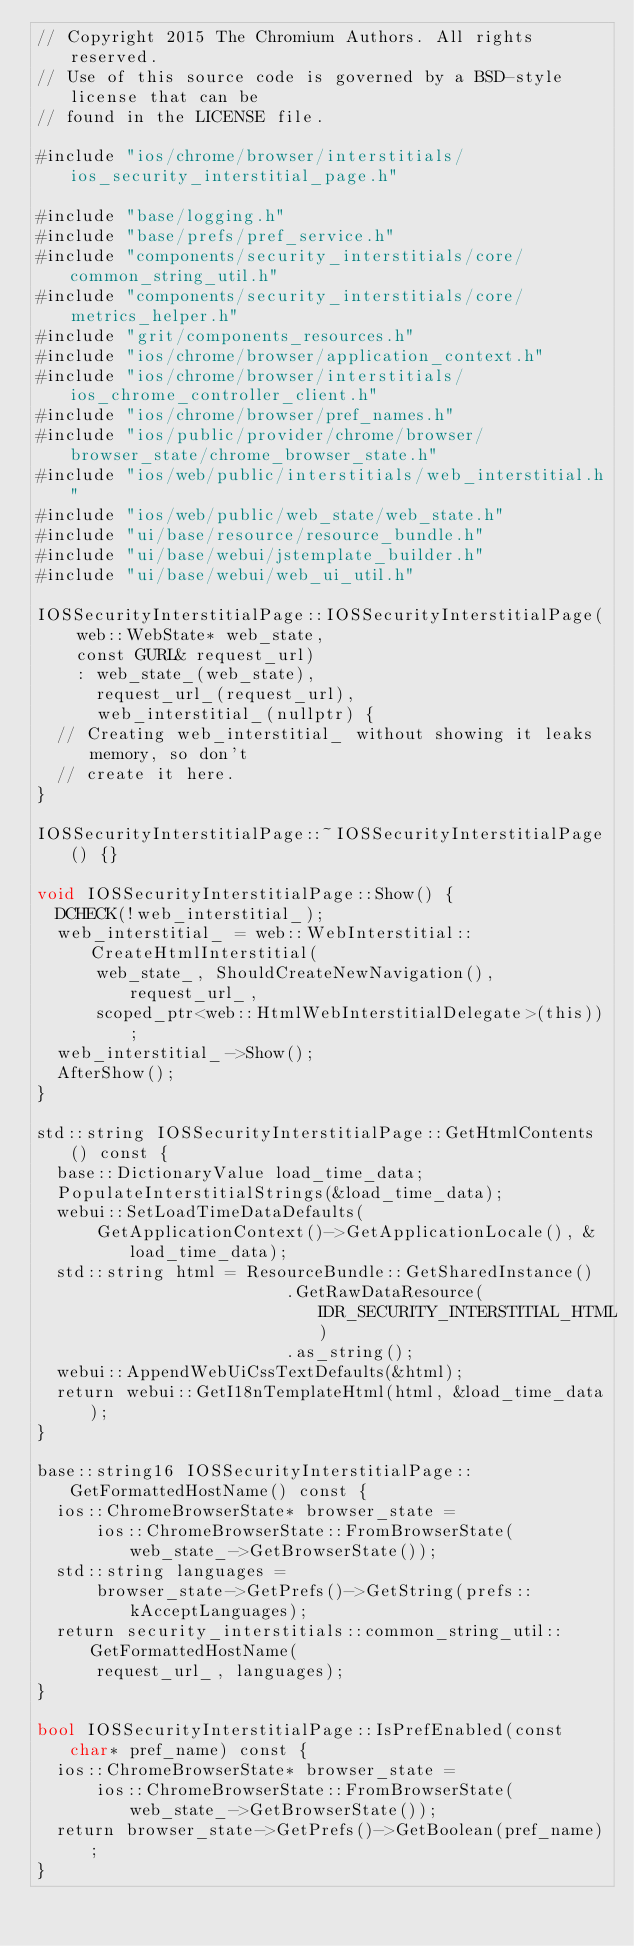<code> <loc_0><loc_0><loc_500><loc_500><_ObjectiveC_>// Copyright 2015 The Chromium Authors. All rights reserved.
// Use of this source code is governed by a BSD-style license that can be
// found in the LICENSE file.

#include "ios/chrome/browser/interstitials/ios_security_interstitial_page.h"

#include "base/logging.h"
#include "base/prefs/pref_service.h"
#include "components/security_interstitials/core/common_string_util.h"
#include "components/security_interstitials/core/metrics_helper.h"
#include "grit/components_resources.h"
#include "ios/chrome/browser/application_context.h"
#include "ios/chrome/browser/interstitials/ios_chrome_controller_client.h"
#include "ios/chrome/browser/pref_names.h"
#include "ios/public/provider/chrome/browser/browser_state/chrome_browser_state.h"
#include "ios/web/public/interstitials/web_interstitial.h"
#include "ios/web/public/web_state/web_state.h"
#include "ui/base/resource/resource_bundle.h"
#include "ui/base/webui/jstemplate_builder.h"
#include "ui/base/webui/web_ui_util.h"

IOSSecurityInterstitialPage::IOSSecurityInterstitialPage(
    web::WebState* web_state,
    const GURL& request_url)
    : web_state_(web_state),
      request_url_(request_url),
      web_interstitial_(nullptr) {
  // Creating web_interstitial_ without showing it leaks memory, so don't
  // create it here.
}

IOSSecurityInterstitialPage::~IOSSecurityInterstitialPage() {}

void IOSSecurityInterstitialPage::Show() {
  DCHECK(!web_interstitial_);
  web_interstitial_ = web::WebInterstitial::CreateHtmlInterstitial(
      web_state_, ShouldCreateNewNavigation(), request_url_,
      scoped_ptr<web::HtmlWebInterstitialDelegate>(this));
  web_interstitial_->Show();
  AfterShow();
}

std::string IOSSecurityInterstitialPage::GetHtmlContents() const {
  base::DictionaryValue load_time_data;
  PopulateInterstitialStrings(&load_time_data);
  webui::SetLoadTimeDataDefaults(
      GetApplicationContext()->GetApplicationLocale(), &load_time_data);
  std::string html = ResourceBundle::GetSharedInstance()
                         .GetRawDataResource(IDR_SECURITY_INTERSTITIAL_HTML)
                         .as_string();
  webui::AppendWebUiCssTextDefaults(&html);
  return webui::GetI18nTemplateHtml(html, &load_time_data);
}

base::string16 IOSSecurityInterstitialPage::GetFormattedHostName() const {
  ios::ChromeBrowserState* browser_state =
      ios::ChromeBrowserState::FromBrowserState(web_state_->GetBrowserState());
  std::string languages =
      browser_state->GetPrefs()->GetString(prefs::kAcceptLanguages);
  return security_interstitials::common_string_util::GetFormattedHostName(
      request_url_, languages);
}

bool IOSSecurityInterstitialPage::IsPrefEnabled(const char* pref_name) const {
  ios::ChromeBrowserState* browser_state =
      ios::ChromeBrowserState::FromBrowserState(web_state_->GetBrowserState());
  return browser_state->GetPrefs()->GetBoolean(pref_name);
}
</code> 